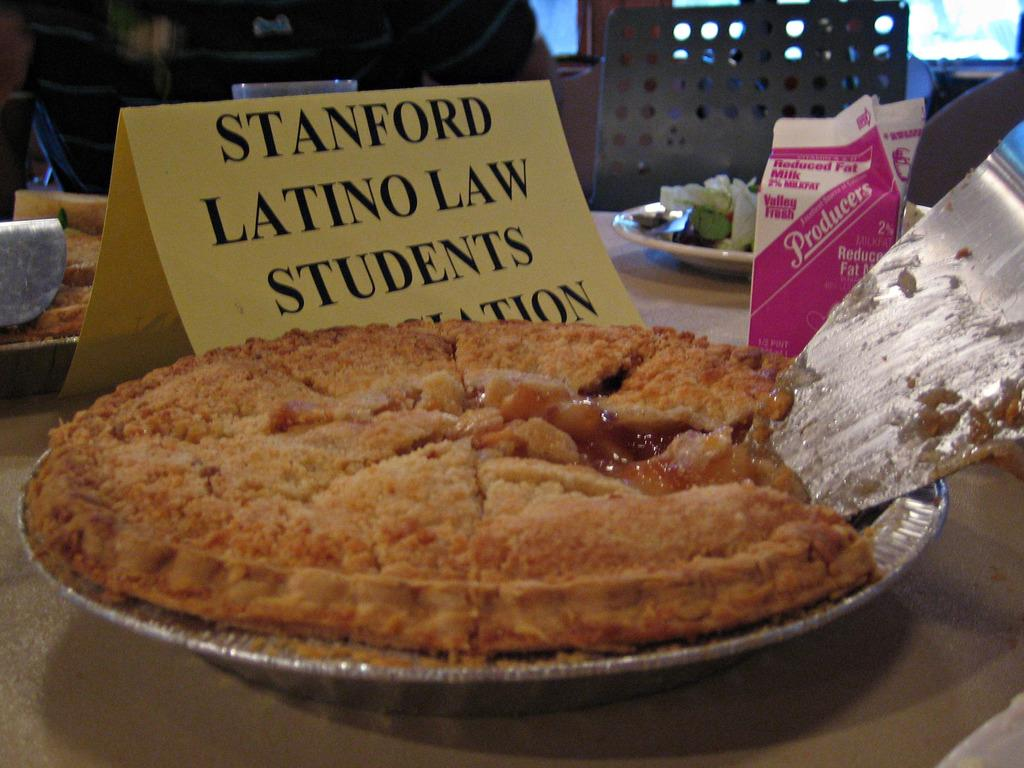What is present on the paper in the image? Something is written on the paper. What else can be seen on the table in the image? There are food items on the table. What type of game is being played on the table in the image? There is no game present on the table in the image; it only contains food items and a paper with writing on it. 